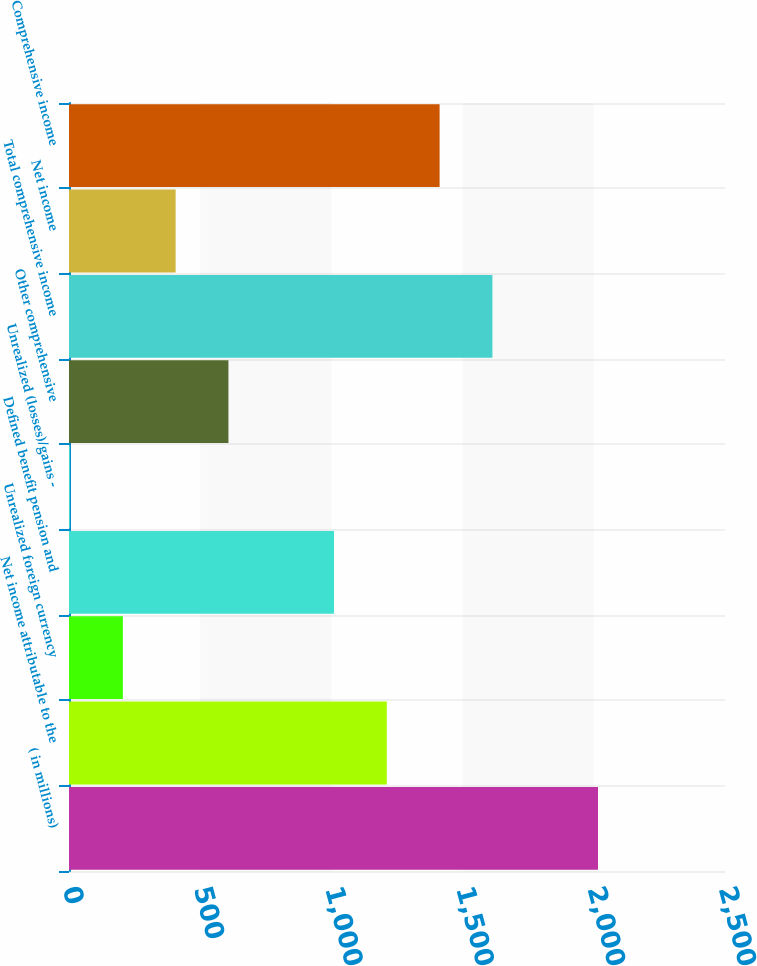Convert chart to OTSL. <chart><loc_0><loc_0><loc_500><loc_500><bar_chart><fcel>( in millions)<fcel>Net income attributable to the<fcel>Unrealized foreign currency<fcel>Defined benefit pension and<fcel>Unrealized (losses)/gains -<fcel>Other comprehensive<fcel>Total comprehensive income<fcel>Net income<fcel>Comprehensive income<nl><fcel>2016<fcel>1211.2<fcel>205.2<fcel>1010<fcel>4<fcel>607.6<fcel>1613.6<fcel>406.4<fcel>1412.4<nl></chart> 